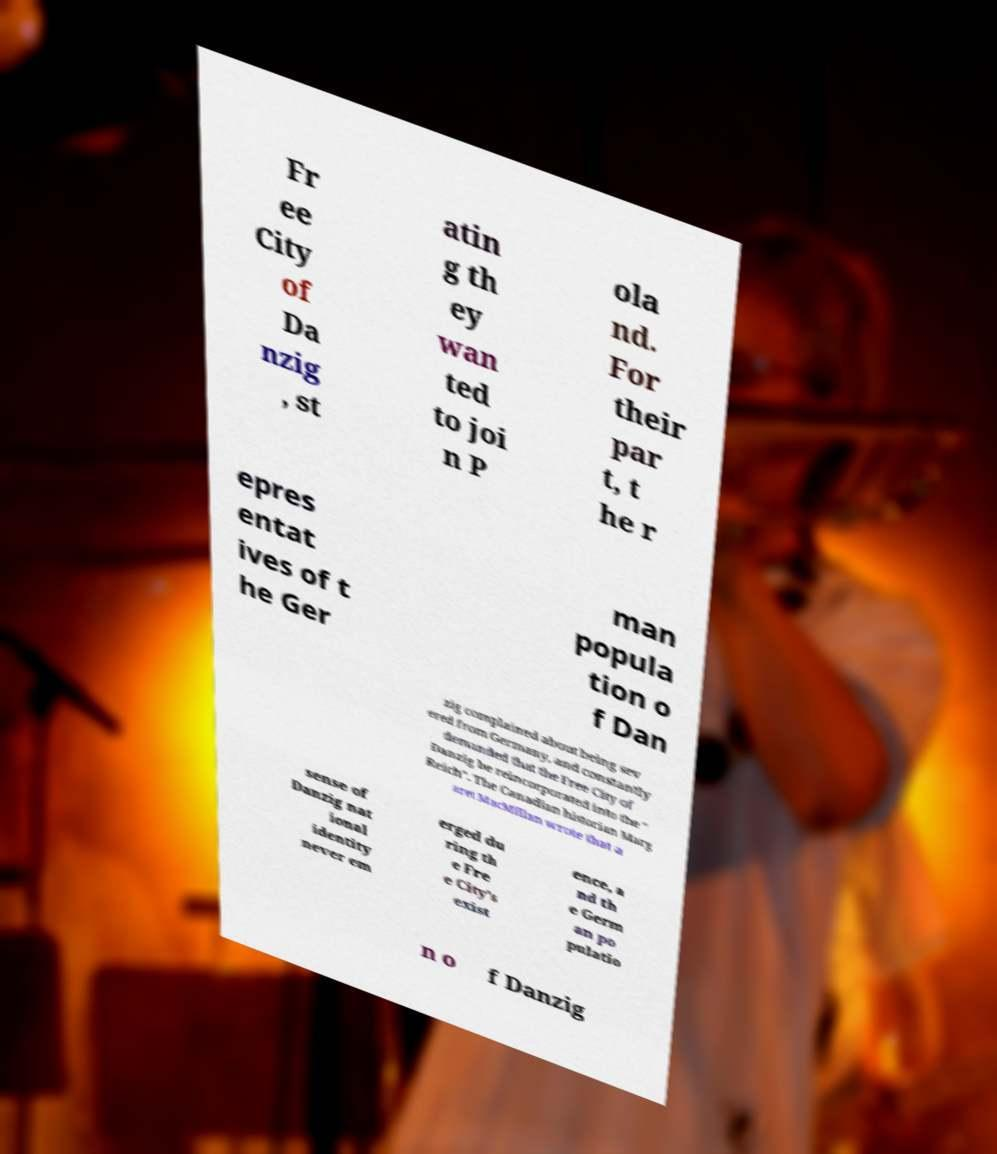I need the written content from this picture converted into text. Can you do that? Fr ee City of Da nzig , st atin g th ey wan ted to joi n P ola nd. For their par t, t he r epres entat ives of t he Ger man popula tion o f Dan zig complained about being sev ered from Germany, and constantly demanded that the Free City of Danzig be reincorporated into the " Reich". The Canadian historian Marg aret MacMillan wrote that a sense of Danzig nat ional identity never em erged du ring th e Fre e City's exist ence, a nd th e Germ an po pulatio n o f Danzig 